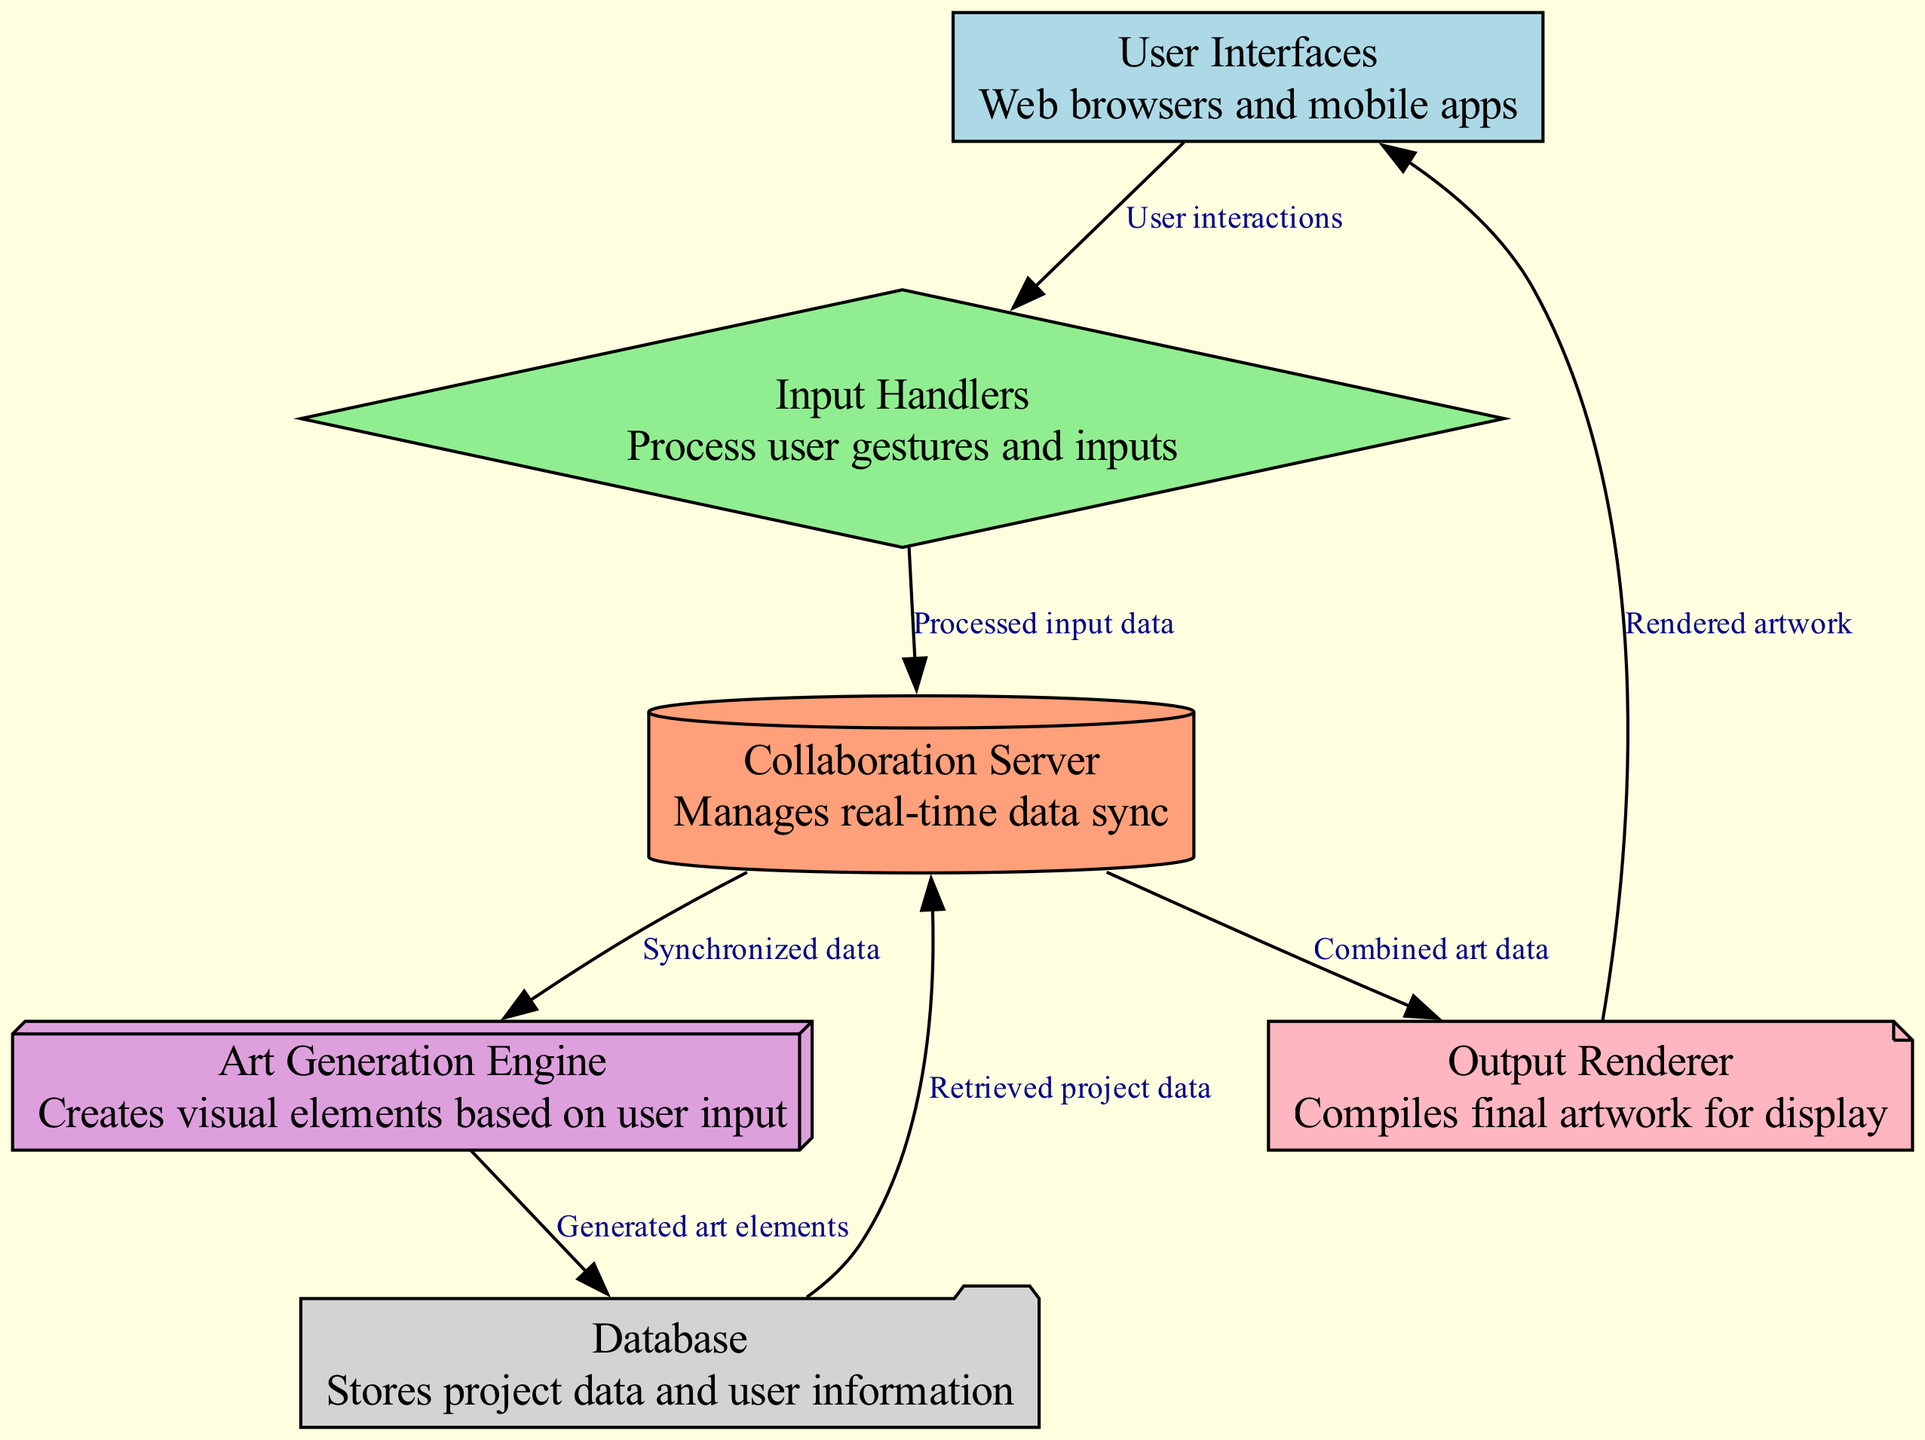What are the types of user interfaces in this diagram? The nodes labeled "User Interfaces" describe "Web browsers and mobile apps." This indicates that these are the primary platforms through which users interact with the system.
Answer: Web browsers and mobile apps How many nodes are present in the diagram? Counting the unique nodes listed in the data, there are six distinct nodes: User Interfaces, Input Handlers, Collaboration Server, Art Generation Engine, Database, and Output Renderer.
Answer: 6 What type of edge connects Input Handlers to Collaboration Server? The edge labeled "Processed input data" indicates the nature of the data being transmitted from Input Handlers to the Collaboration Server.
Answer: Processed input data Which node retrieves project data, and from where? The Database node retrieves project data and sends it back to the Collaboration Server. This is specified in the edge labeled "Retrieved project data."
Answer: Collaboration Server from Database What is the flow of data from Collaboration Server to Output Renderer? The flow starts at the Collaboration Server, which sends "Combined art data" to the Output Renderer. This illustrates how the server compiles information before passing it to be rendered.
Answer: Combined art data to Output Renderer Which nodes are involved in the generation of visual elements? The Art Generation Engine is the primary node responsible for creating visual elements, and it receives synchronized data from the Collaboration Server to do so.
Answer: Art Generation Engine How many edges connect to the Collaboration Server? There are three edges that connect to the Collaboration Server, indicating the different data interactions with this node: from Input Handlers, from Database, and to Art Generation Engine and Output Renderer.
Answer: 3 What indicates the final output in this diagram? The final output is indicated by the edge from the Output Renderer back to User Interfaces, labeled "Rendered artwork," showing that the produced art is displayed to users.
Answer: Rendered artwork What type of node represents the Storage component in this system? The Database node represents the storage component, described as storing project data and user information, which is critical for managing the collaborative experience.
Answer: Database 